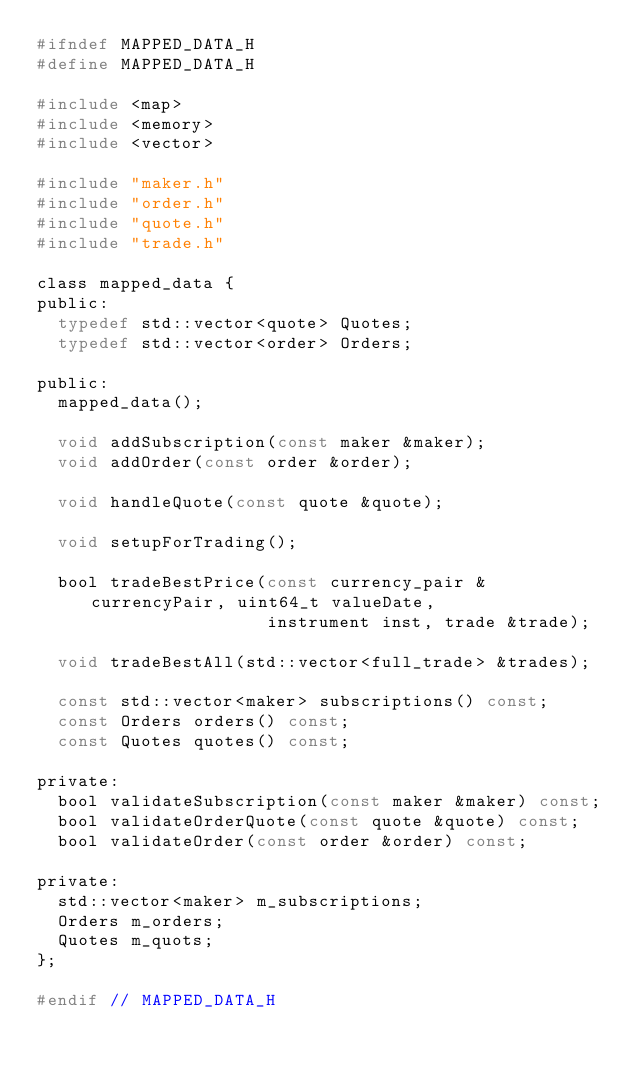Convert code to text. <code><loc_0><loc_0><loc_500><loc_500><_C_>#ifndef MAPPED_DATA_H
#define MAPPED_DATA_H

#include <map>
#include <memory>
#include <vector>

#include "maker.h"
#include "order.h"
#include "quote.h"
#include "trade.h"

class mapped_data {
public:
  typedef std::vector<quote> Quotes;
  typedef std::vector<order> Orders;

public:
  mapped_data();

  void addSubscription(const maker &maker);
  void addOrder(const order &order);

  void handleQuote(const quote &quote);

  void setupForTrading();

  bool tradeBestPrice(const currency_pair &currencyPair, uint64_t valueDate,
                      instrument inst, trade &trade);

  void tradeBestAll(std::vector<full_trade> &trades);

  const std::vector<maker> subscriptions() const;
  const Orders orders() const;
  const Quotes quotes() const;

private:
  bool validateSubscription(const maker &maker) const;
  bool validateOrderQuote(const quote &quote) const;
  bool validateOrder(const order &order) const;

private:
  std::vector<maker> m_subscriptions;
  Orders m_orders;
  Quotes m_quots;
};

#endif // MAPPED_DATA_H
</code> 